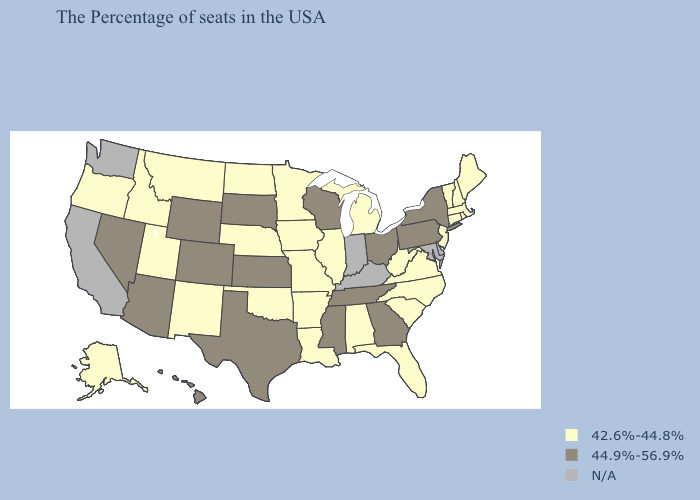Does Hawaii have the lowest value in the West?
Answer briefly. No. Does Nevada have the highest value in the USA?
Keep it brief. Yes. What is the lowest value in states that border Nebraska?
Write a very short answer. 42.6%-44.8%. What is the value of New York?
Keep it brief. 44.9%-56.9%. What is the lowest value in the West?
Keep it brief. 42.6%-44.8%. What is the lowest value in states that border New Mexico?
Give a very brief answer. 42.6%-44.8%. What is the value of Mississippi?
Write a very short answer. 44.9%-56.9%. Which states hav the highest value in the MidWest?
Short answer required. Ohio, Wisconsin, Kansas, South Dakota. What is the lowest value in the South?
Quick response, please. 42.6%-44.8%. Name the states that have a value in the range N/A?
Be succinct. Delaware, Maryland, Kentucky, Indiana, California, Washington. What is the highest value in states that border New Jersey?
Keep it brief. 44.9%-56.9%. Which states have the lowest value in the MidWest?
Concise answer only. Michigan, Illinois, Missouri, Minnesota, Iowa, Nebraska, North Dakota. Name the states that have a value in the range N/A?
Give a very brief answer. Delaware, Maryland, Kentucky, Indiana, California, Washington. Does the first symbol in the legend represent the smallest category?
Quick response, please. Yes. Does the map have missing data?
Give a very brief answer. Yes. 